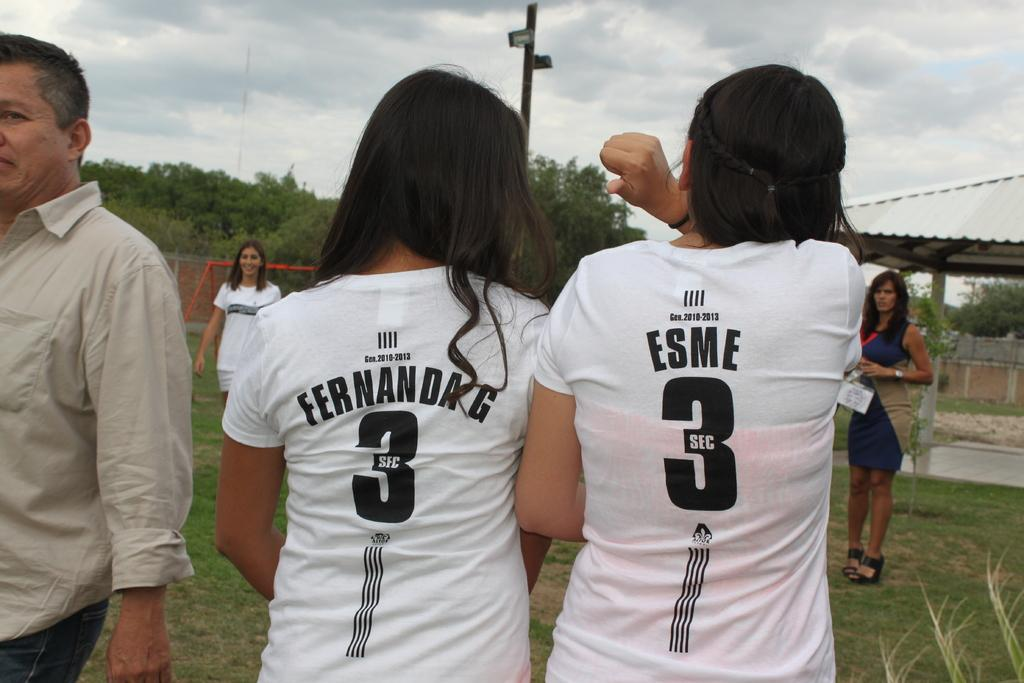<image>
Write a terse but informative summary of the picture. Fernanda G and Esme stand next to each other in their uniforms. 